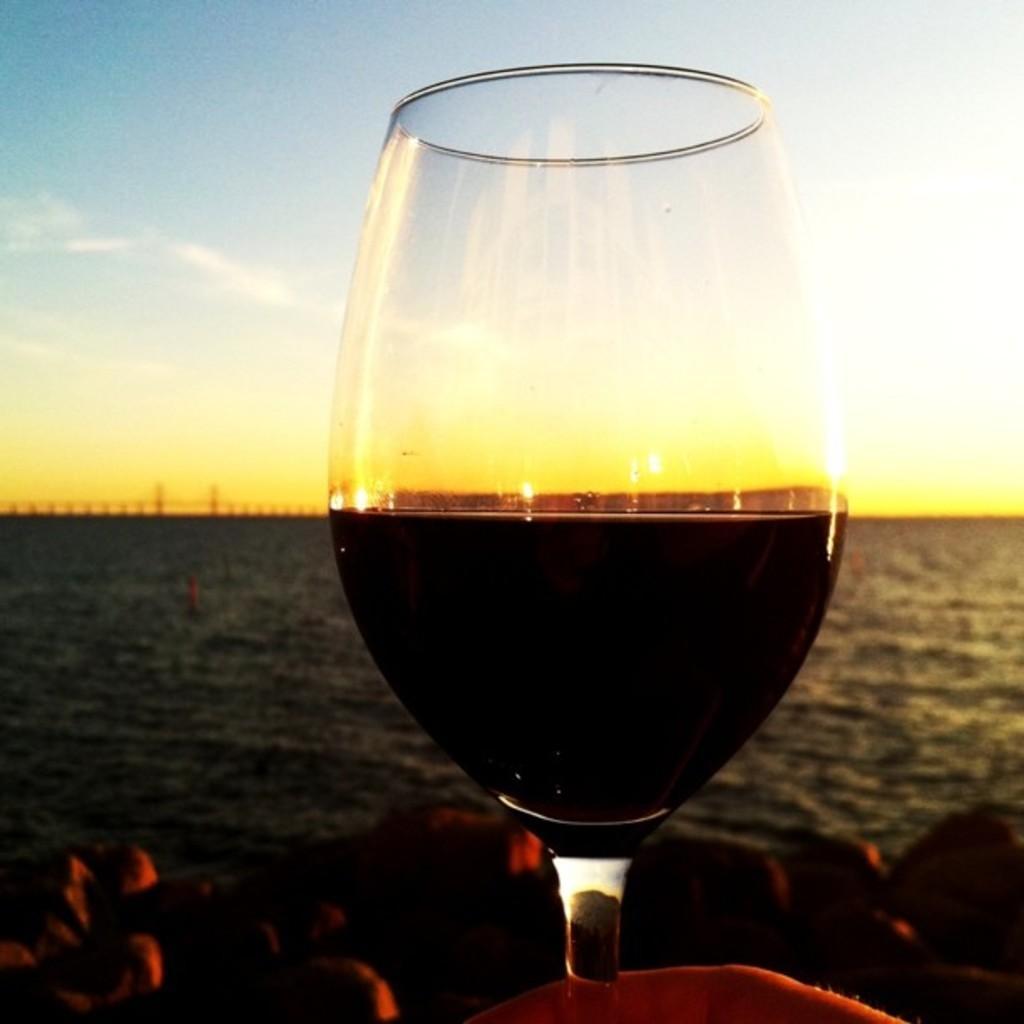Can you describe this image briefly? In this image I can see the glass, water and the sky is in blue, white and yellow color. 